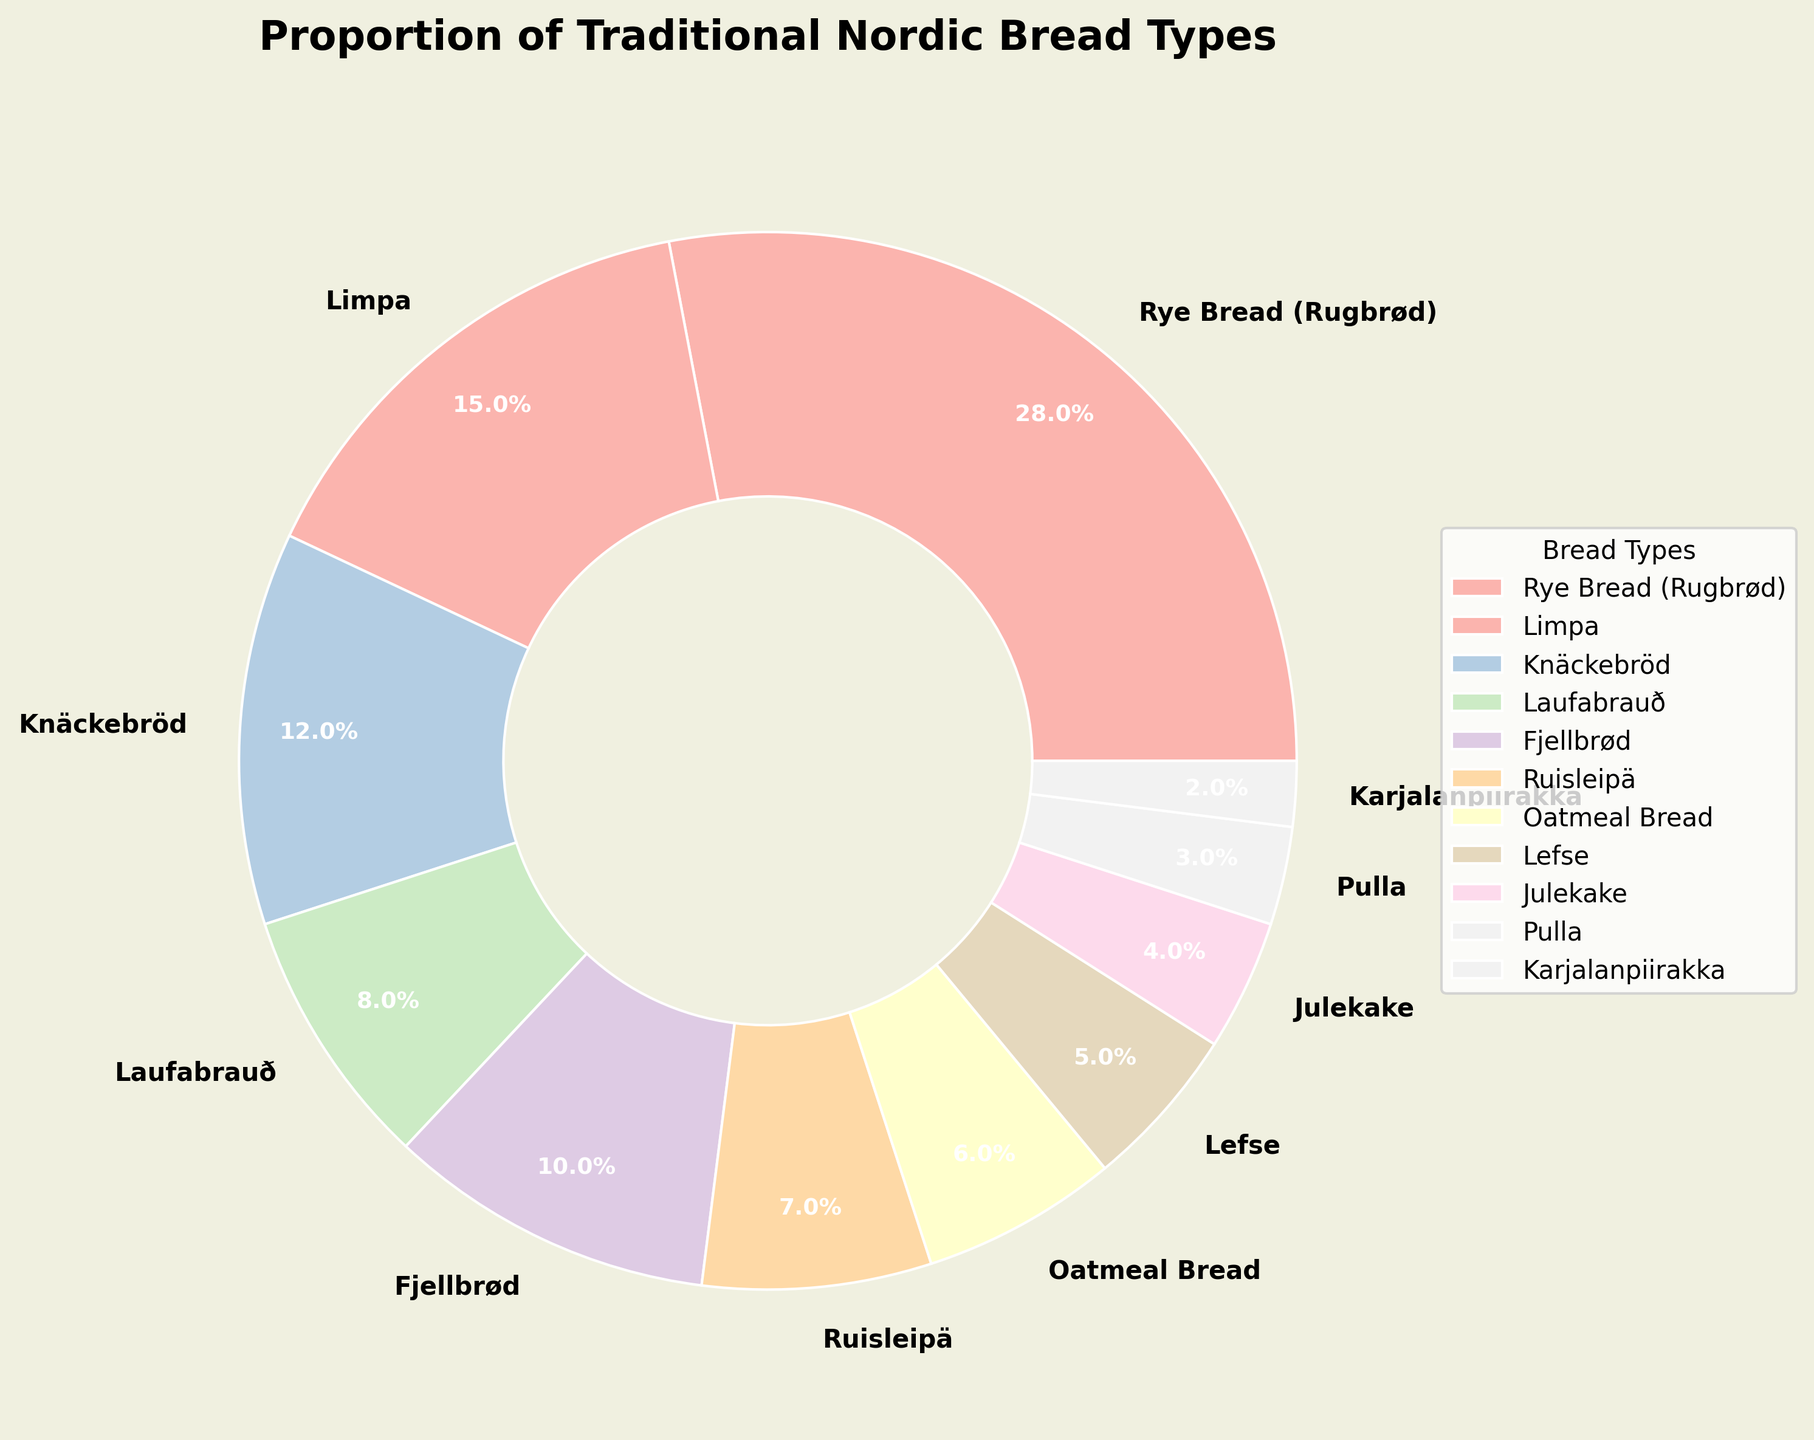What percentage of discussions involve Rye Bread (Rugbrød)? The pie chart labels indicate the percentage for each bread type. By looking at the "Rye Bread (Rugbrød)" section, the corresponding percentage is directly given.
Answer: 28% Which bread types are discussed more than Lefse but less than Rye Bread (Rugbrød)? From the pie chart, Rye Bread (Rugbrød) is 28% and Lefse is 5%. Thus, we need the bread types with percentages between these values. Limpa (15%), Knäckebröd (12%), Laufabrauð (8%), and Fjellbrød (10%) fall in this range.
Answer: Limpa, Knäckebröd, Laufabrauð, Fjellbrød What is the combined percentage of Laufabrauð and Lefse discussions? According to the pie chart, Laufabrauð is 8% and Lefse is 5%. Adding these two percentages together yields 8% + 5% = 13%.
Answer: 13% Which bread type has the smallest proportion of forums' discussions? The pie chart shows each bread type's proportion. "Karjalanpiirakka" has the smallest slice with a 2% share.
Answer: Karjalanpiirakka How much less discussed is Pulla compared to Limpa? Pulla has 3% of the discussions and Limpa has 15%. The difference is calculated by subtracting Pulla's percentage from Limpa's percentage: 15% - 3% = 12%.
Answer: 12% What is the total percentage of discussions for the bread types having less than 10% share each? Bread types with less than 10% share are Laufabrauð (8%), Ruisleipä (7%), Oatmeal Bread (6%), Lefse (5%), Julekake (4%), Pulla (3%), and Karjalanpiirakka (2%). Summing these gives: 8% + 7% + 6% + 5% + 4% + 3% + 2% = 35%.
Answer: 35% Is the portion of Laufabrauð discussions larger than the combined portion of Julekake and Pulla? The pie chart shows Laufabrauð at 8%, Julekake at 4%, and Pulla at 3%. Combining Julekake and Pulla gives: 4% + 3% = 7%. Hence, Laufabrauð (8%) is larger than 7%.
Answer: Yes If you combine Fjellbrød and Knäckebröd discussions, will it be over or under 25%? Fjellbrød is 10% and Knäckebröd is 12%. Adding these two: 10% + 12% = 22%, which is under 25%.
Answer: Under How many bread types have a discussion proportion of 10% or more? From the pie chart, the bread types with 10% or more are Rye Bread (Rugbrød) at 28%, Limpa at 15%, Knäckebröd at 12%, and Fjellbrød at 10%, which totals to 4 bread types.
Answer: 4 Which bread types have their proportion shown between Laufabrauð and Ruisleipä? Laufabrauð is at 8% and Ruisleipä is at 7%. Referring to the pie chart, there are no bread types with percentages between these values.
Answer: None 